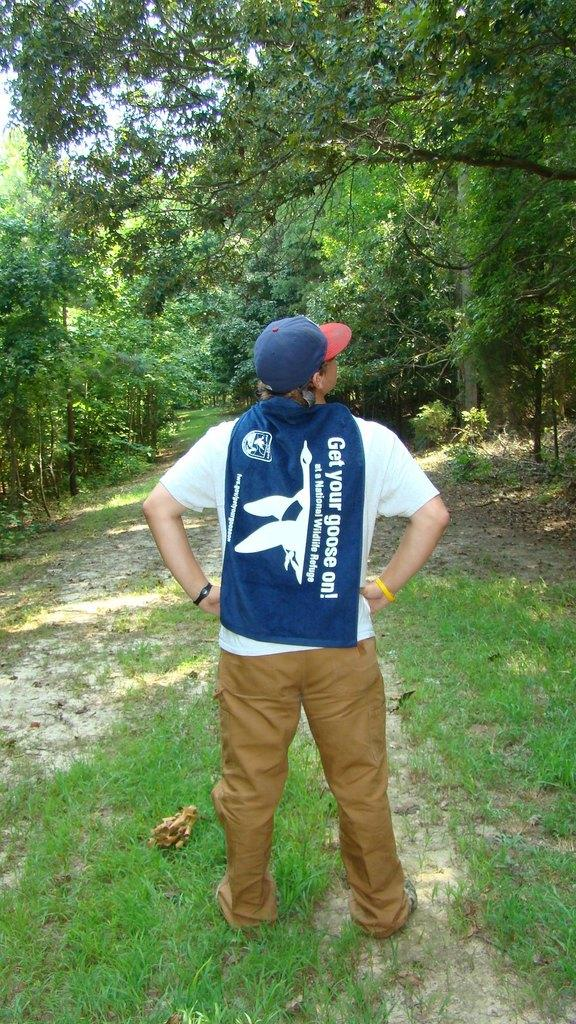Provide a one-sentence caption for the provided image. a man wearing a blue cape that says 'get your goose on'. 